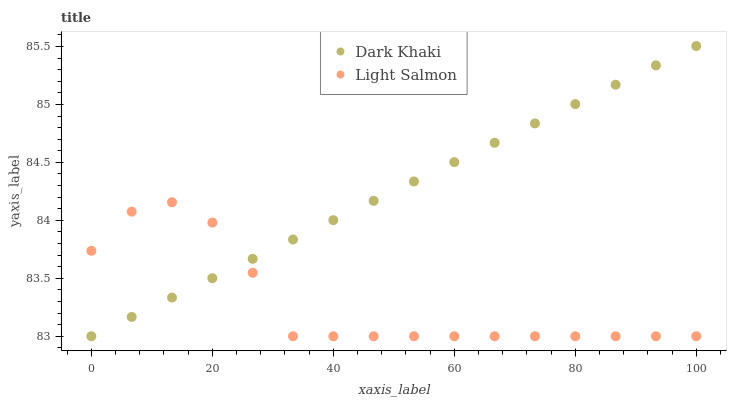Does Light Salmon have the minimum area under the curve?
Answer yes or no. Yes. Does Dark Khaki have the maximum area under the curve?
Answer yes or no. Yes. Does Light Salmon have the maximum area under the curve?
Answer yes or no. No. Is Dark Khaki the smoothest?
Answer yes or no. Yes. Is Light Salmon the roughest?
Answer yes or no. Yes. Is Light Salmon the smoothest?
Answer yes or no. No. Does Dark Khaki have the lowest value?
Answer yes or no. Yes. Does Dark Khaki have the highest value?
Answer yes or no. Yes. Does Light Salmon have the highest value?
Answer yes or no. No. Does Dark Khaki intersect Light Salmon?
Answer yes or no. Yes. Is Dark Khaki less than Light Salmon?
Answer yes or no. No. Is Dark Khaki greater than Light Salmon?
Answer yes or no. No. 